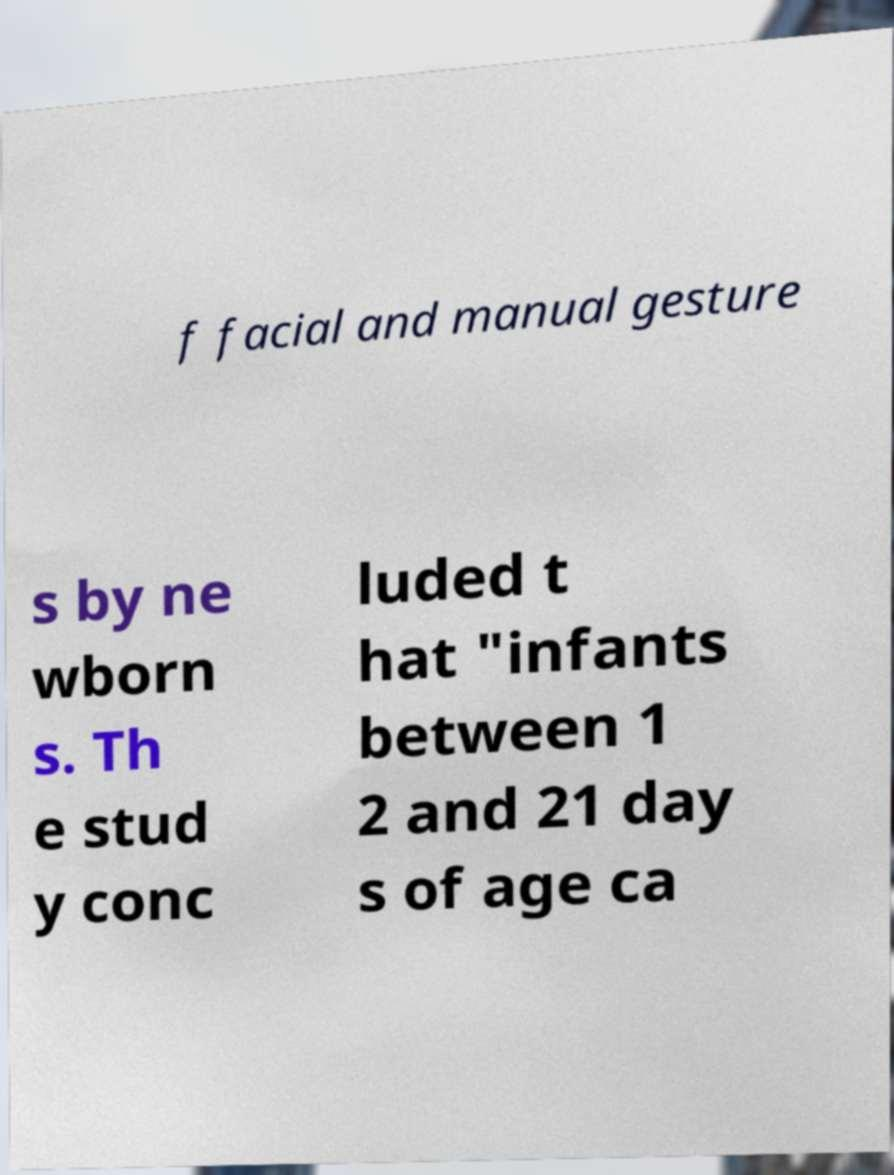For documentation purposes, I need the text within this image transcribed. Could you provide that? f facial and manual gesture s by ne wborn s. Th e stud y conc luded t hat "infants between 1 2 and 21 day s of age ca 